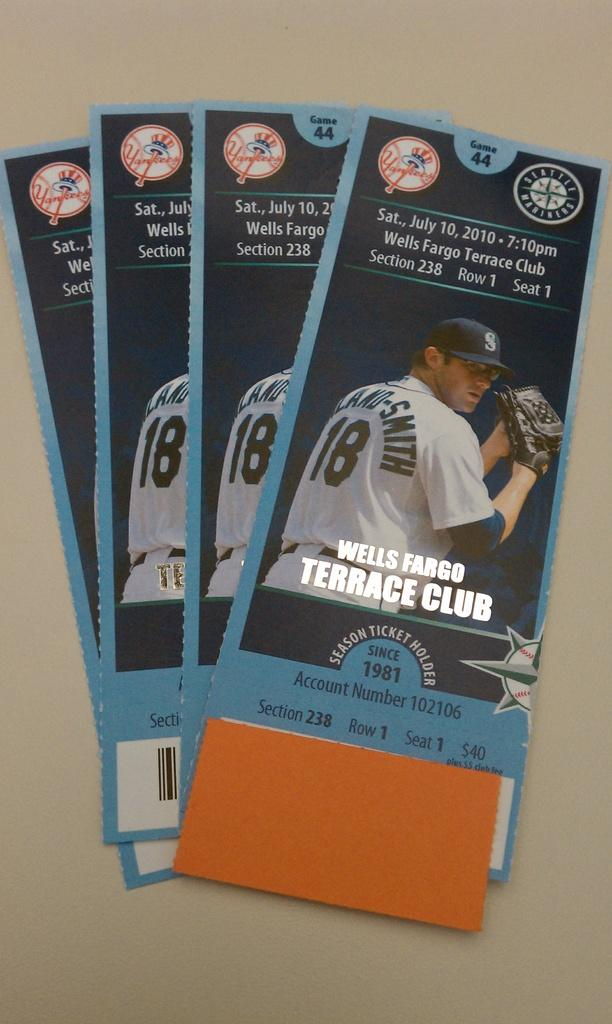<image>
Present a compact description of the photo's key features. Four tickets for a baseball game that says it is game 44 